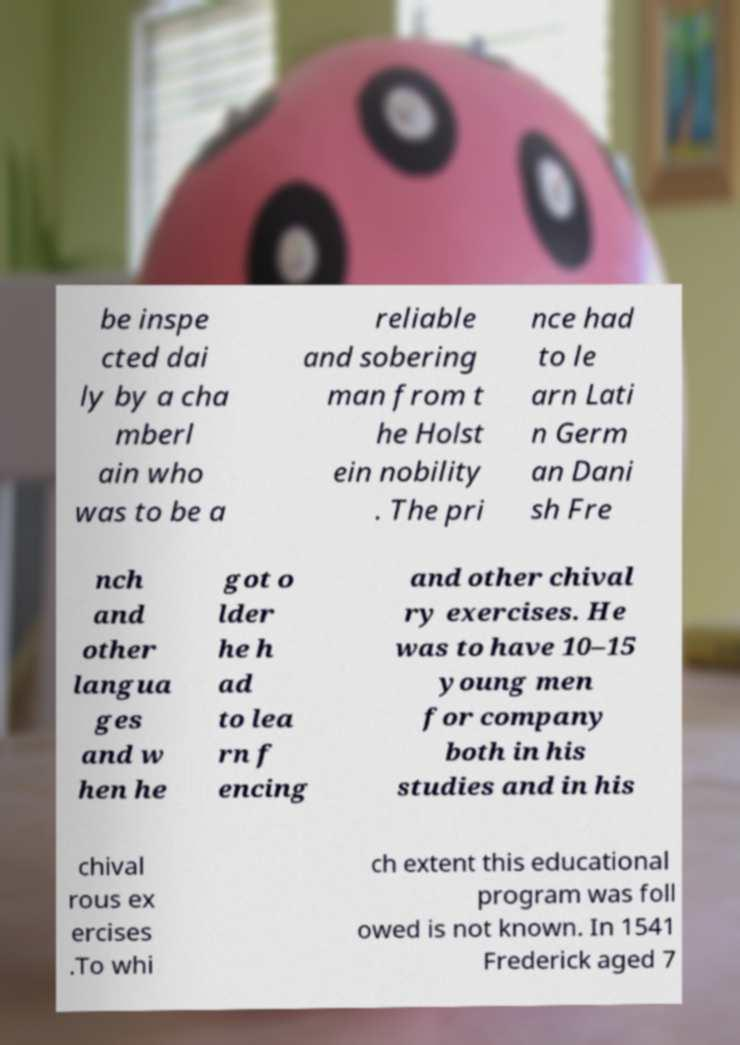Could you assist in decoding the text presented in this image and type it out clearly? be inspe cted dai ly by a cha mberl ain who was to be a reliable and sobering man from t he Holst ein nobility . The pri nce had to le arn Lati n Germ an Dani sh Fre nch and other langua ges and w hen he got o lder he h ad to lea rn f encing and other chival ry exercises. He was to have 10–15 young men for company both in his studies and in his chival rous ex ercises .To whi ch extent this educational program was foll owed is not known. In 1541 Frederick aged 7 